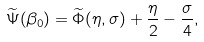Convert formula to latex. <formula><loc_0><loc_0><loc_500><loc_500>\widetilde { \Psi } ( \beta _ { 0 } ) = \widetilde { \Phi } ( \eta , \sigma ) + \frac { \eta } { 2 } - \frac { \sigma } { 4 } ,</formula> 